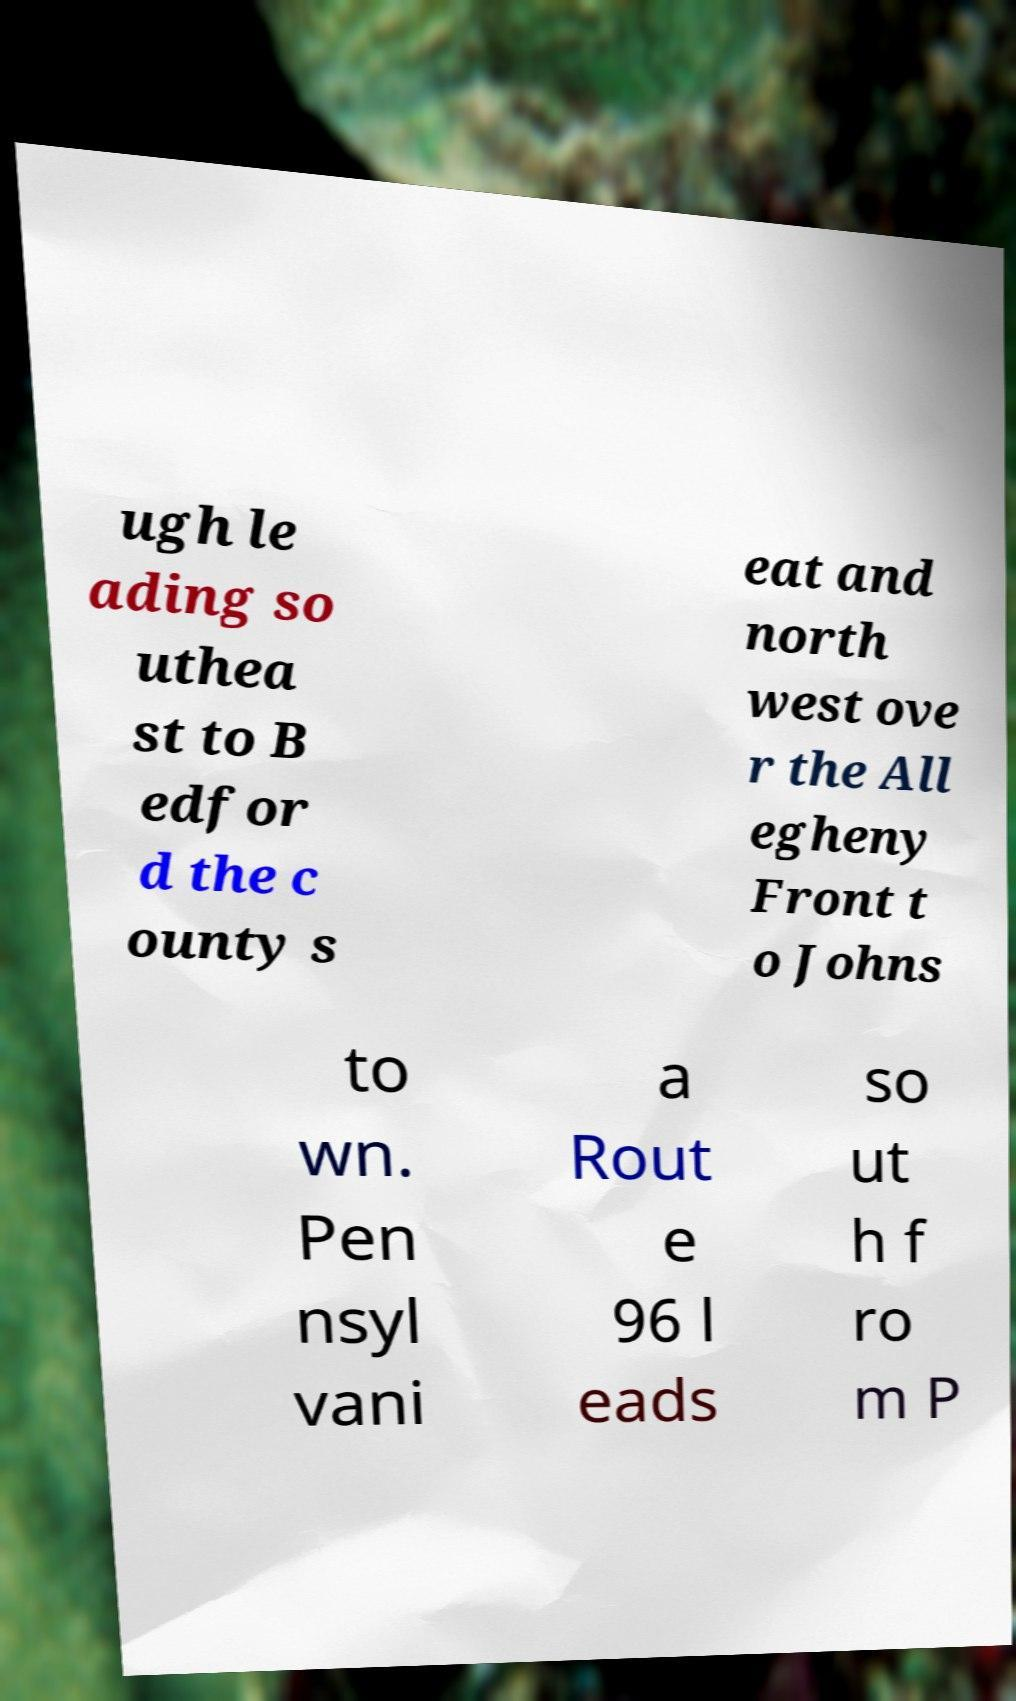Please read and relay the text visible in this image. What does it say? ugh le ading so uthea st to B edfor d the c ounty s eat and north west ove r the All egheny Front t o Johns to wn. Pen nsyl vani a Rout e 96 l eads so ut h f ro m P 